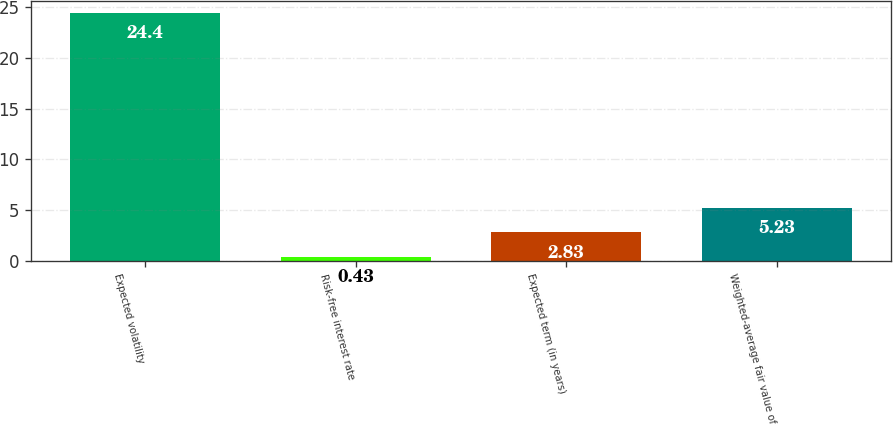Convert chart. <chart><loc_0><loc_0><loc_500><loc_500><bar_chart><fcel>Expected volatility<fcel>Risk-free interest rate<fcel>Expected term (in years)<fcel>Weighted-average fair value of<nl><fcel>24.4<fcel>0.43<fcel>2.83<fcel>5.23<nl></chart> 